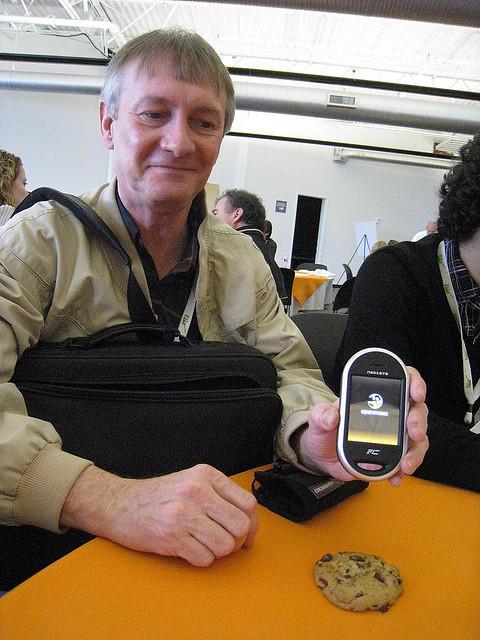Is there a cookie on the table?
Be succinct. Yes. What type of device is this man displaying in his left hand?
Be succinct. Phone. Is this man old enough to drink alcohol?
Concise answer only. Yes. 